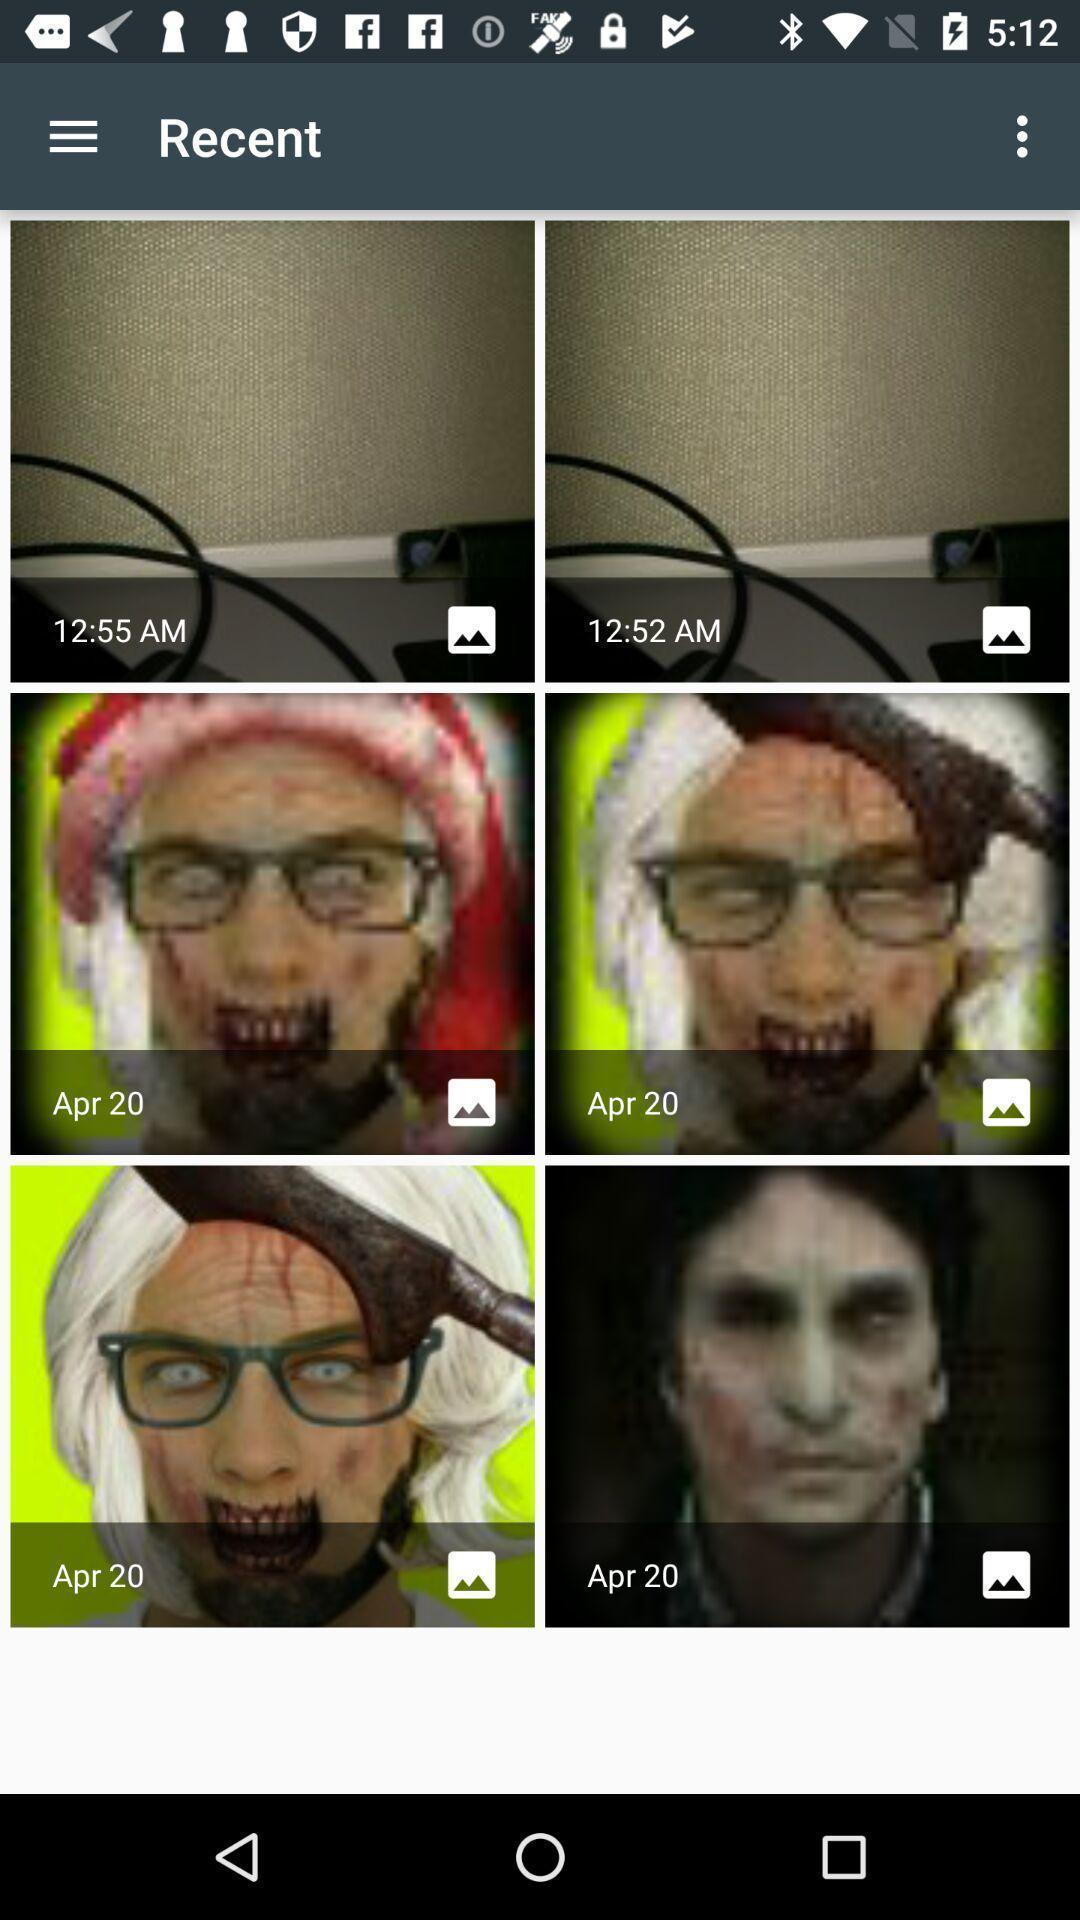Describe this image in words. Screen shows recent images. 